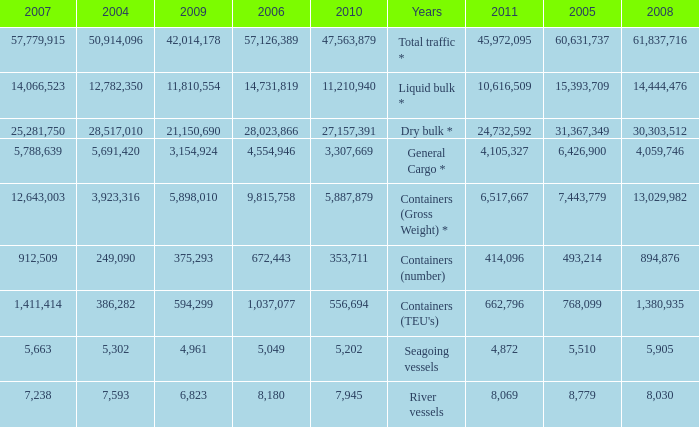What is the highest value in 2011 with less than 5,049 in 2006 and less than 1,380,935 in 2008? None. 